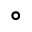Convert formula to latex. <formula><loc_0><loc_0><loc_500><loc_500>^ { \circ }</formula> 